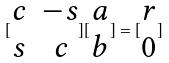Convert formula to latex. <formula><loc_0><loc_0><loc_500><loc_500>[ \begin{matrix} c & - s \\ s & c \end{matrix} ] [ \begin{matrix} a \\ b \end{matrix} ] = [ \begin{matrix} r \\ 0 \end{matrix} ]</formula> 